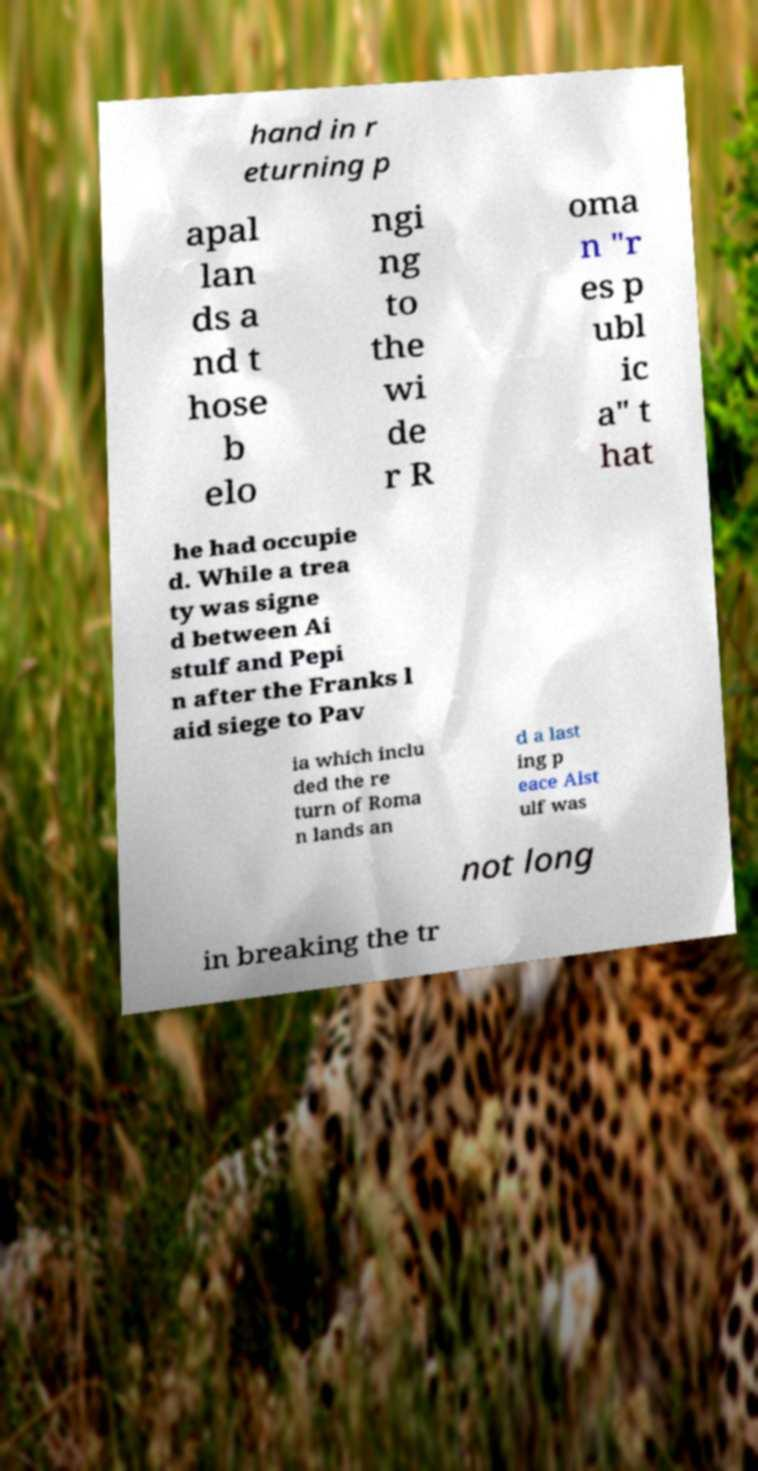There's text embedded in this image that I need extracted. Can you transcribe it verbatim? hand in r eturning p apal lan ds a nd t hose b elo ngi ng to the wi de r R oma n "r es p ubl ic a" t hat he had occupie d. While a trea ty was signe d between Ai stulf and Pepi n after the Franks l aid siege to Pav ia which inclu ded the re turn of Roma n lands an d a last ing p eace Aist ulf was not long in breaking the tr 